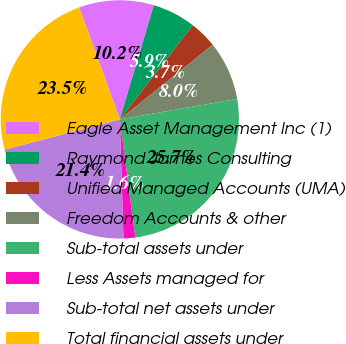Convert chart to OTSL. <chart><loc_0><loc_0><loc_500><loc_500><pie_chart><fcel>Eagle Asset Management Inc (1)<fcel>Raymond James Consulting<fcel>Unified Managed Accounts (UMA)<fcel>Freedom Accounts & other<fcel>Sub-total assets under<fcel>Less Assets managed for<fcel>Sub-total net assets under<fcel>Total financial assets under<nl><fcel>10.16%<fcel>5.88%<fcel>3.74%<fcel>8.02%<fcel>25.68%<fcel>1.59%<fcel>21.4%<fcel>23.54%<nl></chart> 